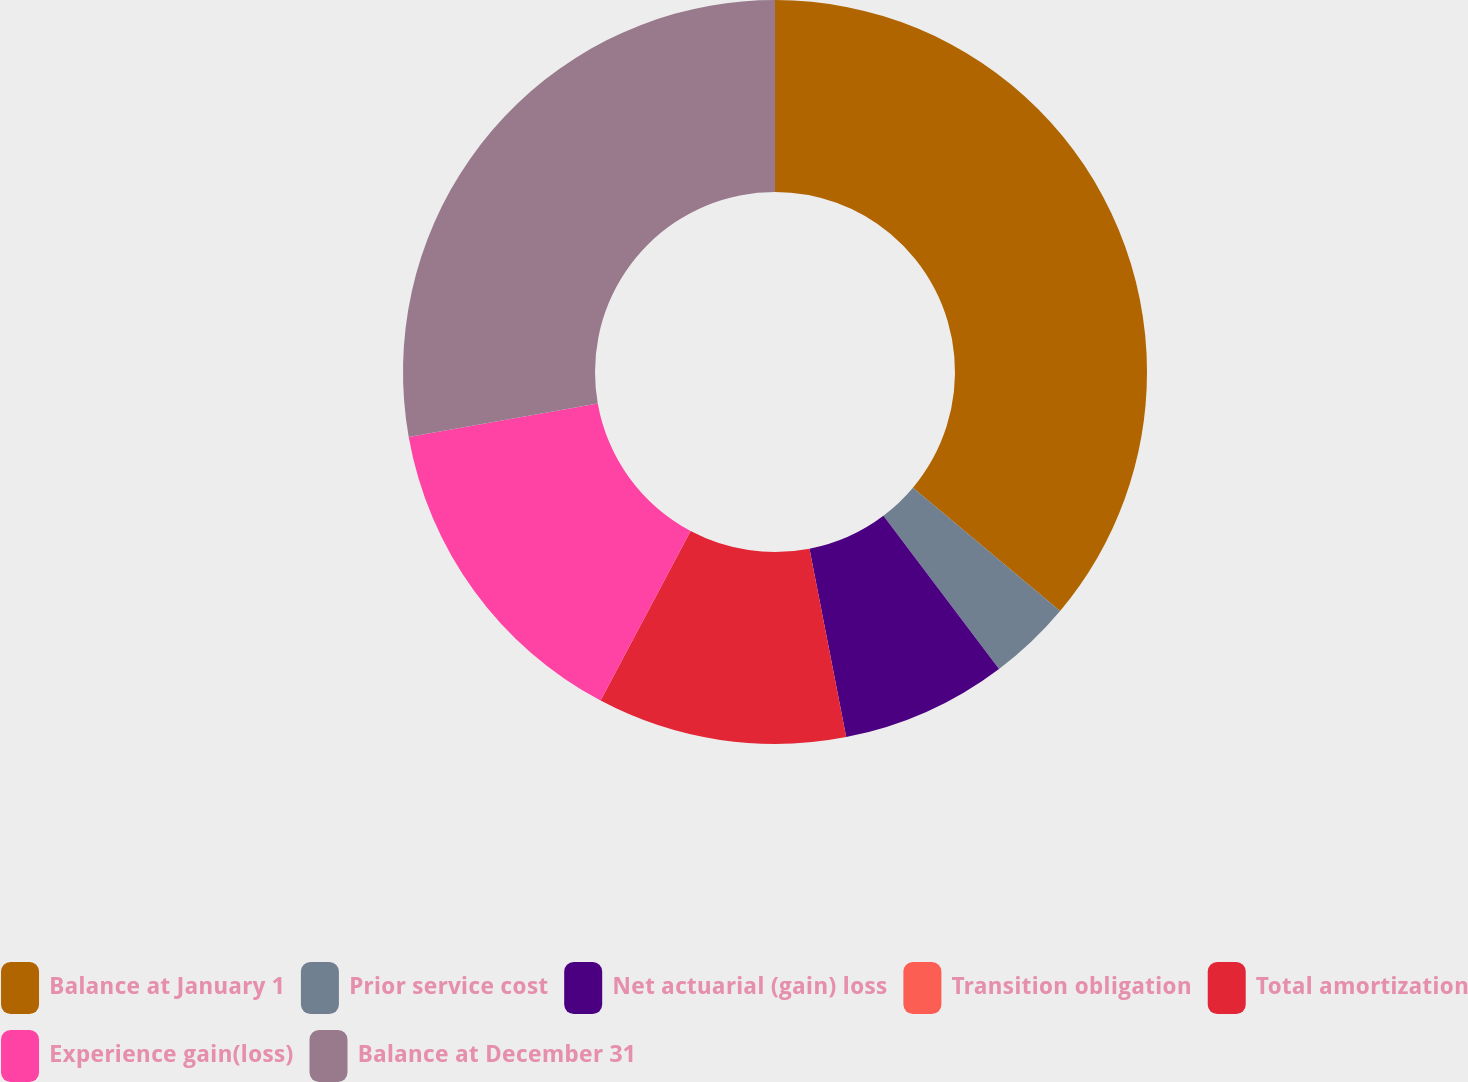<chart> <loc_0><loc_0><loc_500><loc_500><pie_chart><fcel>Balance at January 1<fcel>Prior service cost<fcel>Net actuarial (gain) loss<fcel>Transition obligation<fcel>Total amortization<fcel>Experience gain(loss)<fcel>Balance at December 31<nl><fcel>36.1%<fcel>3.61%<fcel>7.22%<fcel>0.0%<fcel>10.83%<fcel>14.44%<fcel>27.79%<nl></chart> 